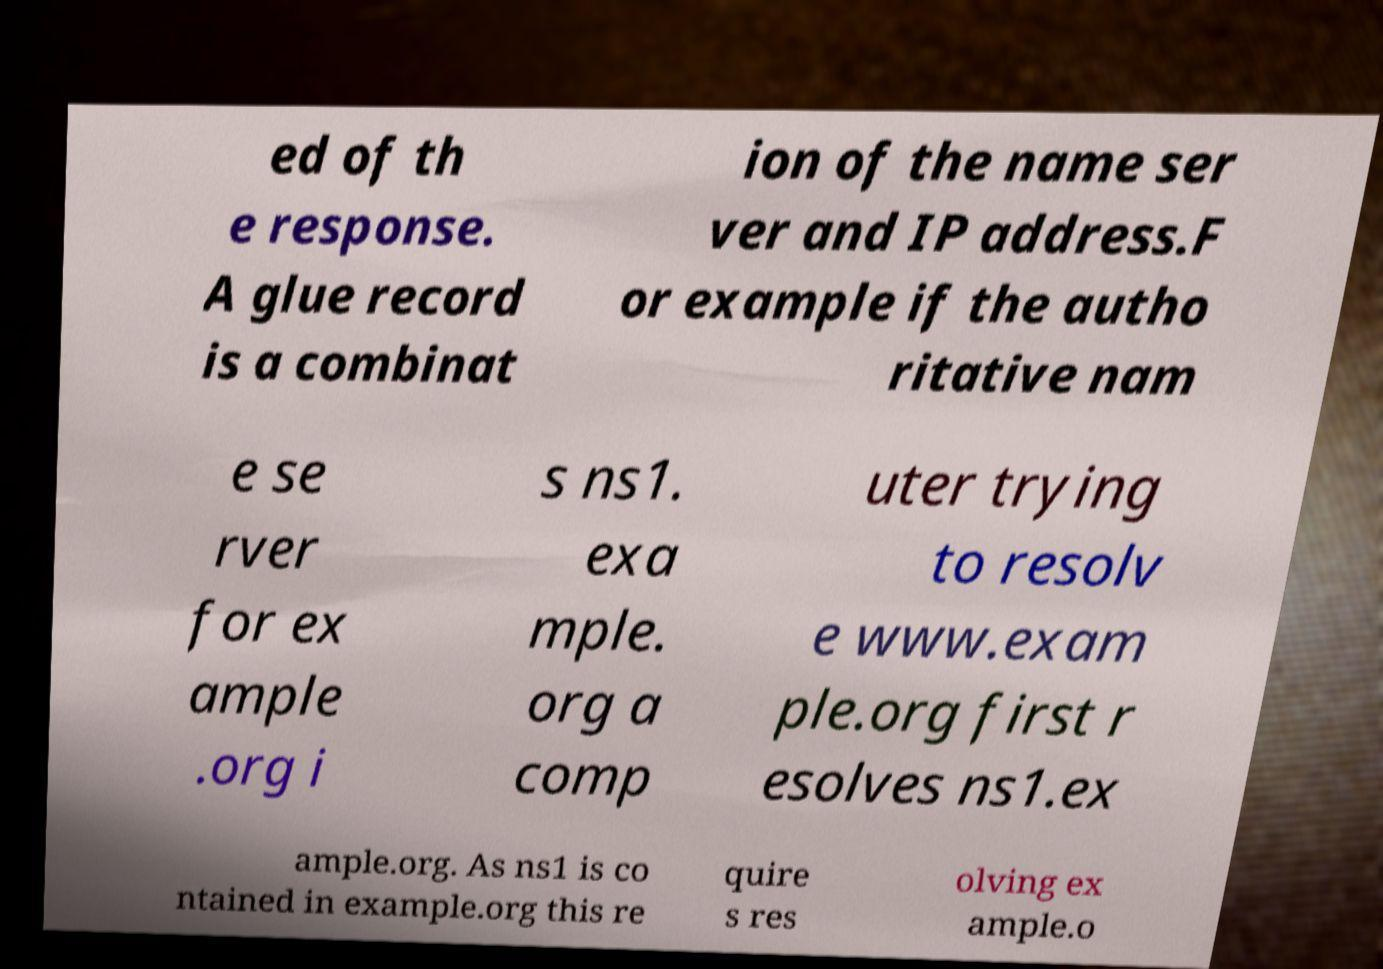Please identify and transcribe the text found in this image. ed of th e response. A glue record is a combinat ion of the name ser ver and IP address.F or example if the autho ritative nam e se rver for ex ample .org i s ns1. exa mple. org a comp uter trying to resolv e www.exam ple.org first r esolves ns1.ex ample.org. As ns1 is co ntained in example.org this re quire s res olving ex ample.o 